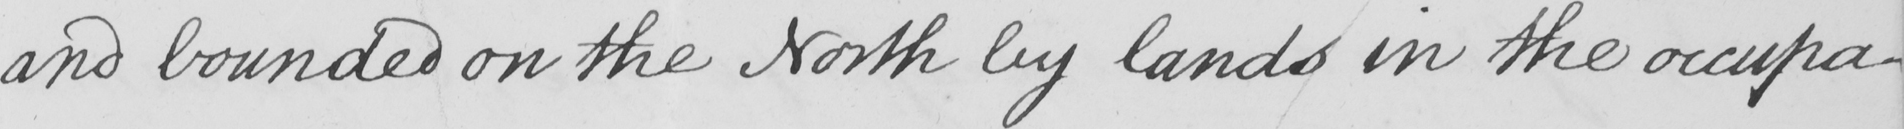Please provide the text content of this handwritten line. and bounded on the North by lands in the occupa- 